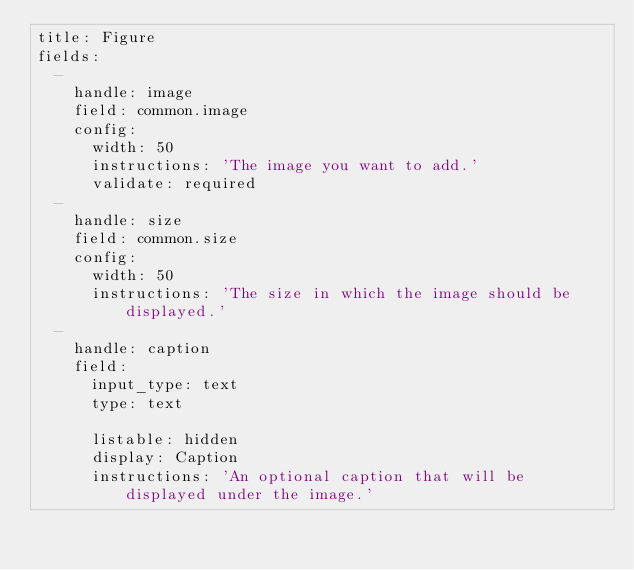<code> <loc_0><loc_0><loc_500><loc_500><_YAML_>title: Figure
fields:
  -
    handle: image
    field: common.image
    config:
      width: 50
      instructions: 'The image you want to add.'
      validate: required
  -
    handle: size
    field: common.size
    config:
      width: 50
      instructions: 'The size in which the image should be displayed.'
  -
    handle: caption
    field:
      input_type: text
      type: text
      
      listable: hidden
      display: Caption
      instructions: 'An optional caption that will be displayed under the image.'
</code> 